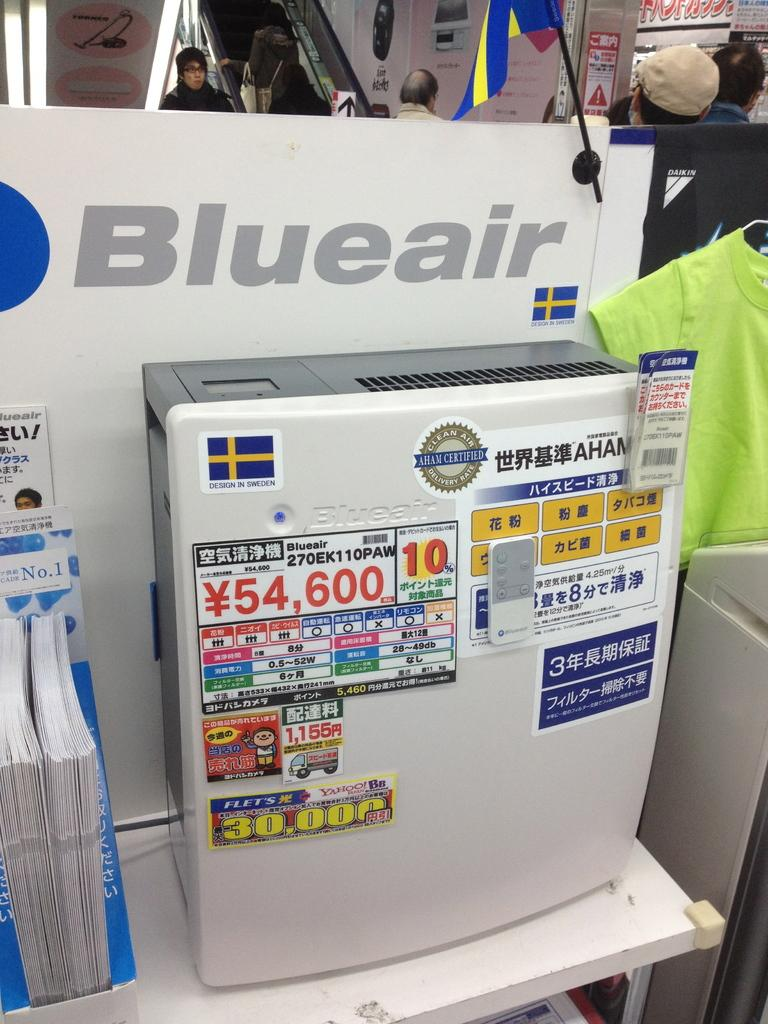Who or what can be seen in the image? There are people in the image. What objects are present in the image? There are tables, boxes, and papers in the image. What is visible in the background of the image? There is a wall with boards in the background of the image. What type of church can be seen in the image? There is no church present in the image. Who is the partner of the person in the image? There is no indication of a partner or relationship between the people in the image. 